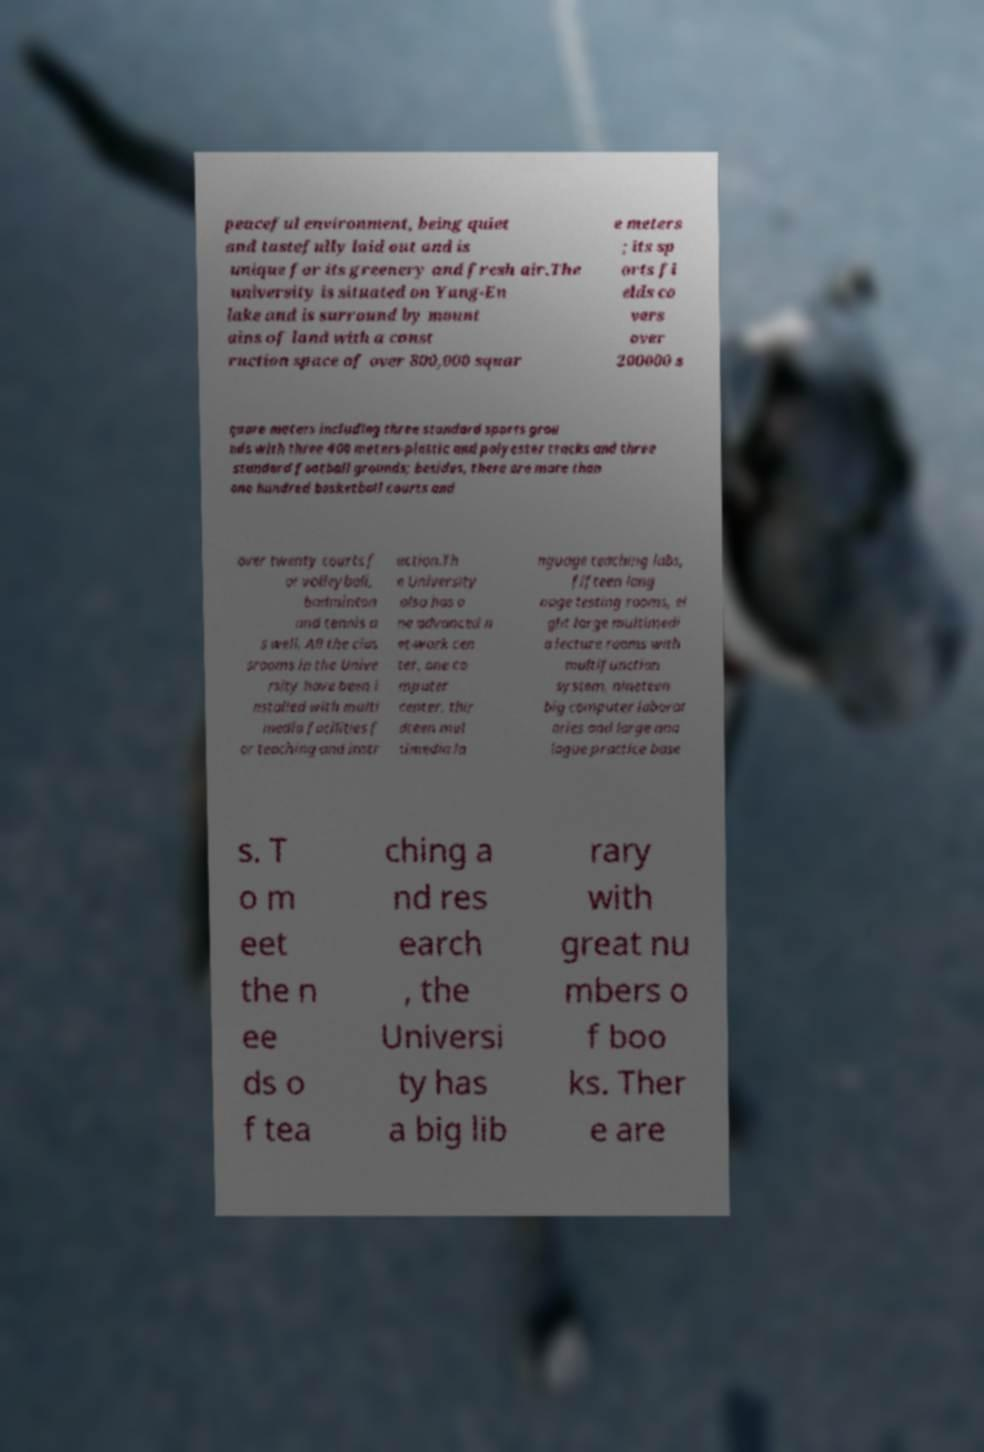Please identify and transcribe the text found in this image. peaceful environment, being quiet and tastefully laid out and is unique for its greenery and fresh air.The university is situated on Yang-En lake and is surround by mount ains of land with a const ruction space of over 800,000 squar e meters ; its sp orts fi elds co vers over 200000 s quare meters including three standard sports grou nds with three 400 meters-plastic and polyester tracks and three standard football grounds; besides, there are more than one hundred basketball courts and over twenty courts f or volleyball, badminton and tennis a s well. All the clas srooms in the Unive rsity have been i nstalled with multi media facilities f or teaching and instr uction.Th e University also has o ne advanced n et-work cen ter, one co mputer center, thir dteen mul timedia la nguage teaching labs, fifteen lang uage testing rooms, ei ght large multimedi a lecture rooms with multifunction system, nineteen big computer laborat ories and large ana logue practice base s. T o m eet the n ee ds o f tea ching a nd res earch , the Universi ty has a big lib rary with great nu mbers o f boo ks. Ther e are 